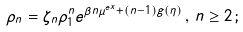<formula> <loc_0><loc_0><loc_500><loc_500>\rho _ { n } = \zeta _ { n } \rho _ { 1 } ^ { n } e ^ { \beta n \mu ^ { e x } + ( n - 1 ) g ( \eta ) } \, , \, n \geq 2 \, ;</formula> 